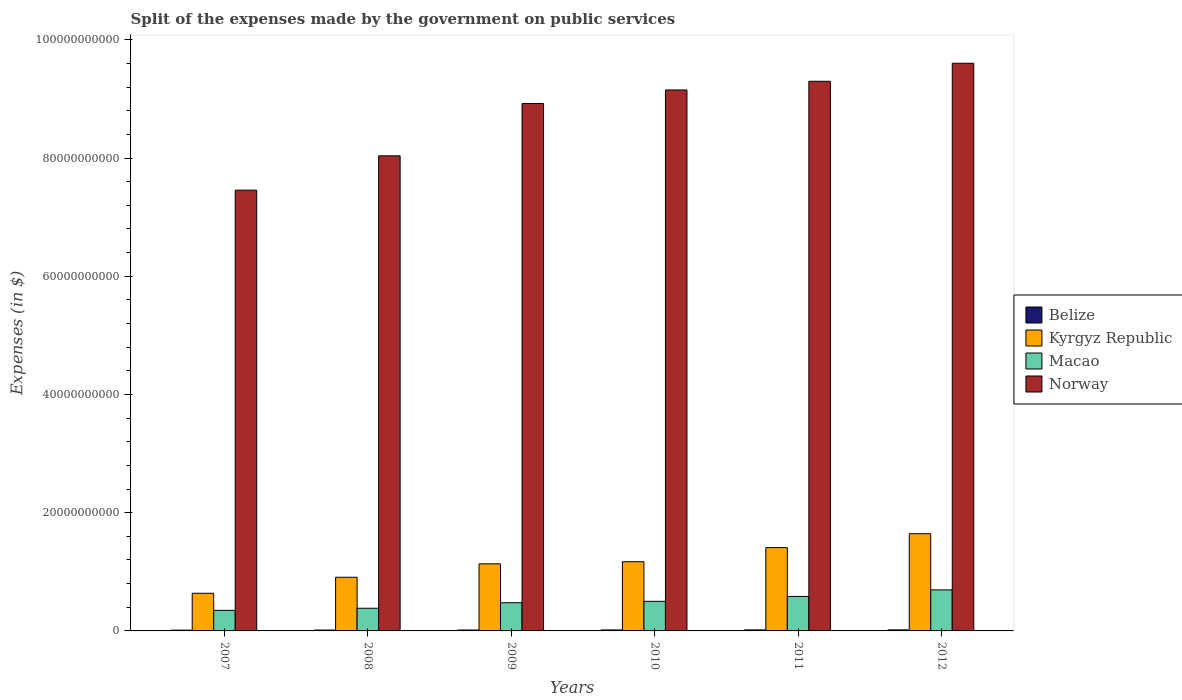How many different coloured bars are there?
Make the answer very short. 4. Are the number of bars per tick equal to the number of legend labels?
Your answer should be very brief. Yes. Are the number of bars on each tick of the X-axis equal?
Your answer should be compact. Yes. What is the expenses made by the government on public services in Kyrgyz Republic in 2010?
Your answer should be compact. 1.17e+1. Across all years, what is the maximum expenses made by the government on public services in Norway?
Your answer should be very brief. 9.60e+1. Across all years, what is the minimum expenses made by the government on public services in Macao?
Keep it short and to the point. 3.48e+09. In which year was the expenses made by the government on public services in Belize maximum?
Your answer should be very brief. 2012. What is the total expenses made by the government on public services in Norway in the graph?
Ensure brevity in your answer.  5.25e+11. What is the difference between the expenses made by the government on public services in Macao in 2009 and that in 2011?
Offer a very short reply. -1.06e+09. What is the difference between the expenses made by the government on public services in Kyrgyz Republic in 2008 and the expenses made by the government on public services in Belize in 2010?
Offer a very short reply. 8.91e+09. What is the average expenses made by the government on public services in Kyrgyz Republic per year?
Your response must be concise. 1.15e+1. In the year 2011, what is the difference between the expenses made by the government on public services in Kyrgyz Republic and expenses made by the government on public services in Macao?
Provide a succinct answer. 8.26e+09. What is the ratio of the expenses made by the government on public services in Macao in 2008 to that in 2011?
Offer a very short reply. 0.66. Is the expenses made by the government on public services in Macao in 2007 less than that in 2011?
Keep it short and to the point. Yes. What is the difference between the highest and the second highest expenses made by the government on public services in Kyrgyz Republic?
Provide a succinct answer. 2.36e+09. What is the difference between the highest and the lowest expenses made by the government on public services in Macao?
Make the answer very short. 3.46e+09. In how many years, is the expenses made by the government on public services in Belize greater than the average expenses made by the government on public services in Belize taken over all years?
Provide a short and direct response. 3. Is the sum of the expenses made by the government on public services in Belize in 2007 and 2012 greater than the maximum expenses made by the government on public services in Kyrgyz Republic across all years?
Provide a succinct answer. No. Is it the case that in every year, the sum of the expenses made by the government on public services in Norway and expenses made by the government on public services in Kyrgyz Republic is greater than the sum of expenses made by the government on public services in Macao and expenses made by the government on public services in Belize?
Provide a short and direct response. Yes. What does the 4th bar from the left in 2009 represents?
Keep it short and to the point. Norway. What does the 4th bar from the right in 2012 represents?
Provide a succinct answer. Belize. Is it the case that in every year, the sum of the expenses made by the government on public services in Norway and expenses made by the government on public services in Belize is greater than the expenses made by the government on public services in Kyrgyz Republic?
Keep it short and to the point. Yes. Does the graph contain any zero values?
Offer a terse response. No. Where does the legend appear in the graph?
Your answer should be very brief. Center right. How are the legend labels stacked?
Keep it short and to the point. Vertical. What is the title of the graph?
Your answer should be compact. Split of the expenses made by the government on public services. What is the label or title of the Y-axis?
Make the answer very short. Expenses (in $). What is the Expenses (in $) in Belize in 2007?
Your answer should be very brief. 1.34e+08. What is the Expenses (in $) of Kyrgyz Republic in 2007?
Provide a succinct answer. 6.37e+09. What is the Expenses (in $) in Macao in 2007?
Give a very brief answer. 3.48e+09. What is the Expenses (in $) in Norway in 2007?
Offer a terse response. 7.46e+1. What is the Expenses (in $) of Belize in 2008?
Make the answer very short. 1.49e+08. What is the Expenses (in $) of Kyrgyz Republic in 2008?
Ensure brevity in your answer.  9.08e+09. What is the Expenses (in $) of Macao in 2008?
Your answer should be very brief. 3.84e+09. What is the Expenses (in $) of Norway in 2008?
Offer a terse response. 8.04e+1. What is the Expenses (in $) of Belize in 2009?
Your response must be concise. 1.58e+08. What is the Expenses (in $) of Kyrgyz Republic in 2009?
Keep it short and to the point. 1.13e+1. What is the Expenses (in $) in Macao in 2009?
Provide a succinct answer. 4.77e+09. What is the Expenses (in $) of Norway in 2009?
Provide a short and direct response. 8.92e+1. What is the Expenses (in $) in Belize in 2010?
Your response must be concise. 1.65e+08. What is the Expenses (in $) of Kyrgyz Republic in 2010?
Offer a terse response. 1.17e+1. What is the Expenses (in $) of Macao in 2010?
Give a very brief answer. 5.01e+09. What is the Expenses (in $) of Norway in 2010?
Your answer should be compact. 9.15e+1. What is the Expenses (in $) in Belize in 2011?
Provide a short and direct response. 1.74e+08. What is the Expenses (in $) of Kyrgyz Republic in 2011?
Give a very brief answer. 1.41e+1. What is the Expenses (in $) in Macao in 2011?
Your answer should be compact. 5.83e+09. What is the Expenses (in $) of Norway in 2011?
Your response must be concise. 9.30e+1. What is the Expenses (in $) of Belize in 2012?
Your answer should be compact. 1.76e+08. What is the Expenses (in $) in Kyrgyz Republic in 2012?
Your answer should be compact. 1.64e+1. What is the Expenses (in $) of Macao in 2012?
Your answer should be compact. 6.94e+09. What is the Expenses (in $) of Norway in 2012?
Make the answer very short. 9.60e+1. Across all years, what is the maximum Expenses (in $) of Belize?
Offer a terse response. 1.76e+08. Across all years, what is the maximum Expenses (in $) in Kyrgyz Republic?
Keep it short and to the point. 1.64e+1. Across all years, what is the maximum Expenses (in $) of Macao?
Offer a terse response. 6.94e+09. Across all years, what is the maximum Expenses (in $) in Norway?
Offer a terse response. 9.60e+1. Across all years, what is the minimum Expenses (in $) in Belize?
Your answer should be compact. 1.34e+08. Across all years, what is the minimum Expenses (in $) in Kyrgyz Republic?
Your answer should be very brief. 6.37e+09. Across all years, what is the minimum Expenses (in $) of Macao?
Provide a succinct answer. 3.48e+09. Across all years, what is the minimum Expenses (in $) in Norway?
Your answer should be very brief. 7.46e+1. What is the total Expenses (in $) of Belize in the graph?
Ensure brevity in your answer.  9.56e+08. What is the total Expenses (in $) of Kyrgyz Republic in the graph?
Give a very brief answer. 6.91e+1. What is the total Expenses (in $) in Macao in the graph?
Offer a very short reply. 2.99e+1. What is the total Expenses (in $) in Norway in the graph?
Your answer should be compact. 5.25e+11. What is the difference between the Expenses (in $) of Belize in 2007 and that in 2008?
Provide a succinct answer. -1.45e+07. What is the difference between the Expenses (in $) in Kyrgyz Republic in 2007 and that in 2008?
Provide a succinct answer. -2.71e+09. What is the difference between the Expenses (in $) of Macao in 2007 and that in 2008?
Keep it short and to the point. -3.57e+08. What is the difference between the Expenses (in $) of Norway in 2007 and that in 2008?
Offer a very short reply. -5.81e+09. What is the difference between the Expenses (in $) of Belize in 2007 and that in 2009?
Provide a succinct answer. -2.38e+07. What is the difference between the Expenses (in $) in Kyrgyz Republic in 2007 and that in 2009?
Keep it short and to the point. -4.98e+09. What is the difference between the Expenses (in $) of Macao in 2007 and that in 2009?
Provide a short and direct response. -1.29e+09. What is the difference between the Expenses (in $) in Norway in 2007 and that in 2009?
Your response must be concise. -1.47e+1. What is the difference between the Expenses (in $) in Belize in 2007 and that in 2010?
Offer a very short reply. -3.07e+07. What is the difference between the Expenses (in $) of Kyrgyz Republic in 2007 and that in 2010?
Offer a very short reply. -5.34e+09. What is the difference between the Expenses (in $) of Macao in 2007 and that in 2010?
Offer a very short reply. -1.53e+09. What is the difference between the Expenses (in $) of Norway in 2007 and that in 2010?
Your response must be concise. -1.70e+1. What is the difference between the Expenses (in $) of Belize in 2007 and that in 2011?
Provide a short and direct response. -3.99e+07. What is the difference between the Expenses (in $) of Kyrgyz Republic in 2007 and that in 2011?
Provide a short and direct response. -7.72e+09. What is the difference between the Expenses (in $) of Macao in 2007 and that in 2011?
Your answer should be very brief. -2.35e+09. What is the difference between the Expenses (in $) in Norway in 2007 and that in 2011?
Provide a succinct answer. -1.84e+1. What is the difference between the Expenses (in $) of Belize in 2007 and that in 2012?
Offer a terse response. -4.19e+07. What is the difference between the Expenses (in $) of Kyrgyz Republic in 2007 and that in 2012?
Keep it short and to the point. -1.01e+1. What is the difference between the Expenses (in $) of Macao in 2007 and that in 2012?
Your response must be concise. -3.46e+09. What is the difference between the Expenses (in $) in Norway in 2007 and that in 2012?
Keep it short and to the point. -2.15e+1. What is the difference between the Expenses (in $) in Belize in 2008 and that in 2009?
Give a very brief answer. -9.31e+06. What is the difference between the Expenses (in $) of Kyrgyz Republic in 2008 and that in 2009?
Provide a succinct answer. -2.27e+09. What is the difference between the Expenses (in $) in Macao in 2008 and that in 2009?
Provide a succinct answer. -9.29e+08. What is the difference between the Expenses (in $) in Norway in 2008 and that in 2009?
Give a very brief answer. -8.85e+09. What is the difference between the Expenses (in $) of Belize in 2008 and that in 2010?
Your answer should be very brief. -1.61e+07. What is the difference between the Expenses (in $) in Kyrgyz Republic in 2008 and that in 2010?
Ensure brevity in your answer.  -2.63e+09. What is the difference between the Expenses (in $) of Macao in 2008 and that in 2010?
Make the answer very short. -1.17e+09. What is the difference between the Expenses (in $) in Norway in 2008 and that in 2010?
Make the answer very short. -1.11e+1. What is the difference between the Expenses (in $) of Belize in 2008 and that in 2011?
Your answer should be very brief. -2.54e+07. What is the difference between the Expenses (in $) of Kyrgyz Republic in 2008 and that in 2011?
Make the answer very short. -5.01e+09. What is the difference between the Expenses (in $) in Macao in 2008 and that in 2011?
Your answer should be compact. -1.99e+09. What is the difference between the Expenses (in $) in Norway in 2008 and that in 2011?
Provide a short and direct response. -1.26e+1. What is the difference between the Expenses (in $) in Belize in 2008 and that in 2012?
Your answer should be compact. -2.74e+07. What is the difference between the Expenses (in $) of Kyrgyz Republic in 2008 and that in 2012?
Keep it short and to the point. -7.37e+09. What is the difference between the Expenses (in $) in Macao in 2008 and that in 2012?
Offer a very short reply. -3.10e+09. What is the difference between the Expenses (in $) in Norway in 2008 and that in 2012?
Your answer should be very brief. -1.57e+1. What is the difference between the Expenses (in $) of Belize in 2009 and that in 2010?
Provide a succinct answer. -6.82e+06. What is the difference between the Expenses (in $) of Kyrgyz Republic in 2009 and that in 2010?
Ensure brevity in your answer.  -3.61e+08. What is the difference between the Expenses (in $) in Macao in 2009 and that in 2010?
Keep it short and to the point. -2.40e+08. What is the difference between the Expenses (in $) of Norway in 2009 and that in 2010?
Offer a terse response. -2.29e+09. What is the difference between the Expenses (in $) in Belize in 2009 and that in 2011?
Your answer should be very brief. -1.61e+07. What is the difference between the Expenses (in $) in Kyrgyz Republic in 2009 and that in 2011?
Keep it short and to the point. -2.74e+09. What is the difference between the Expenses (in $) in Macao in 2009 and that in 2011?
Provide a succinct answer. -1.06e+09. What is the difference between the Expenses (in $) of Norway in 2009 and that in 2011?
Provide a short and direct response. -3.76e+09. What is the difference between the Expenses (in $) in Belize in 2009 and that in 2012?
Provide a short and direct response. -1.80e+07. What is the difference between the Expenses (in $) in Kyrgyz Republic in 2009 and that in 2012?
Give a very brief answer. -5.10e+09. What is the difference between the Expenses (in $) in Macao in 2009 and that in 2012?
Provide a succinct answer. -2.17e+09. What is the difference between the Expenses (in $) of Norway in 2009 and that in 2012?
Offer a very short reply. -6.81e+09. What is the difference between the Expenses (in $) of Belize in 2010 and that in 2011?
Make the answer very short. -9.27e+06. What is the difference between the Expenses (in $) of Kyrgyz Republic in 2010 and that in 2011?
Ensure brevity in your answer.  -2.38e+09. What is the difference between the Expenses (in $) in Macao in 2010 and that in 2011?
Your answer should be very brief. -8.24e+08. What is the difference between the Expenses (in $) in Norway in 2010 and that in 2011?
Your answer should be very brief. -1.47e+09. What is the difference between the Expenses (in $) in Belize in 2010 and that in 2012?
Keep it short and to the point. -1.12e+07. What is the difference between the Expenses (in $) in Kyrgyz Republic in 2010 and that in 2012?
Your answer should be compact. -4.74e+09. What is the difference between the Expenses (in $) in Macao in 2010 and that in 2012?
Offer a very short reply. -1.93e+09. What is the difference between the Expenses (in $) in Norway in 2010 and that in 2012?
Offer a very short reply. -4.52e+09. What is the difference between the Expenses (in $) in Belize in 2011 and that in 2012?
Your response must be concise. -1.96e+06. What is the difference between the Expenses (in $) of Kyrgyz Republic in 2011 and that in 2012?
Offer a terse response. -2.36e+09. What is the difference between the Expenses (in $) of Macao in 2011 and that in 2012?
Your answer should be very brief. -1.11e+09. What is the difference between the Expenses (in $) of Norway in 2011 and that in 2012?
Your answer should be very brief. -3.05e+09. What is the difference between the Expenses (in $) in Belize in 2007 and the Expenses (in $) in Kyrgyz Republic in 2008?
Ensure brevity in your answer.  -8.95e+09. What is the difference between the Expenses (in $) of Belize in 2007 and the Expenses (in $) of Macao in 2008?
Your answer should be very brief. -3.70e+09. What is the difference between the Expenses (in $) in Belize in 2007 and the Expenses (in $) in Norway in 2008?
Offer a terse response. -8.02e+1. What is the difference between the Expenses (in $) of Kyrgyz Republic in 2007 and the Expenses (in $) of Macao in 2008?
Offer a very short reply. 2.53e+09. What is the difference between the Expenses (in $) in Kyrgyz Republic in 2007 and the Expenses (in $) in Norway in 2008?
Your response must be concise. -7.40e+1. What is the difference between the Expenses (in $) of Macao in 2007 and the Expenses (in $) of Norway in 2008?
Make the answer very short. -7.69e+1. What is the difference between the Expenses (in $) of Belize in 2007 and the Expenses (in $) of Kyrgyz Republic in 2009?
Your answer should be very brief. -1.12e+1. What is the difference between the Expenses (in $) in Belize in 2007 and the Expenses (in $) in Macao in 2009?
Your answer should be very brief. -4.63e+09. What is the difference between the Expenses (in $) in Belize in 2007 and the Expenses (in $) in Norway in 2009?
Your answer should be very brief. -8.91e+1. What is the difference between the Expenses (in $) in Kyrgyz Republic in 2007 and the Expenses (in $) in Macao in 2009?
Provide a succinct answer. 1.60e+09. What is the difference between the Expenses (in $) of Kyrgyz Republic in 2007 and the Expenses (in $) of Norway in 2009?
Offer a terse response. -8.29e+1. What is the difference between the Expenses (in $) in Macao in 2007 and the Expenses (in $) in Norway in 2009?
Ensure brevity in your answer.  -8.57e+1. What is the difference between the Expenses (in $) of Belize in 2007 and the Expenses (in $) of Kyrgyz Republic in 2010?
Offer a terse response. -1.16e+1. What is the difference between the Expenses (in $) in Belize in 2007 and the Expenses (in $) in Macao in 2010?
Provide a short and direct response. -4.87e+09. What is the difference between the Expenses (in $) in Belize in 2007 and the Expenses (in $) in Norway in 2010?
Keep it short and to the point. -9.14e+1. What is the difference between the Expenses (in $) in Kyrgyz Republic in 2007 and the Expenses (in $) in Macao in 2010?
Offer a terse response. 1.36e+09. What is the difference between the Expenses (in $) in Kyrgyz Republic in 2007 and the Expenses (in $) in Norway in 2010?
Provide a succinct answer. -8.51e+1. What is the difference between the Expenses (in $) of Macao in 2007 and the Expenses (in $) of Norway in 2010?
Your answer should be compact. -8.80e+1. What is the difference between the Expenses (in $) of Belize in 2007 and the Expenses (in $) of Kyrgyz Republic in 2011?
Ensure brevity in your answer.  -1.40e+1. What is the difference between the Expenses (in $) in Belize in 2007 and the Expenses (in $) in Macao in 2011?
Your response must be concise. -5.70e+09. What is the difference between the Expenses (in $) in Belize in 2007 and the Expenses (in $) in Norway in 2011?
Give a very brief answer. -9.29e+1. What is the difference between the Expenses (in $) in Kyrgyz Republic in 2007 and the Expenses (in $) in Macao in 2011?
Ensure brevity in your answer.  5.41e+08. What is the difference between the Expenses (in $) in Kyrgyz Republic in 2007 and the Expenses (in $) in Norway in 2011?
Your answer should be compact. -8.66e+1. What is the difference between the Expenses (in $) in Macao in 2007 and the Expenses (in $) in Norway in 2011?
Ensure brevity in your answer.  -8.95e+1. What is the difference between the Expenses (in $) in Belize in 2007 and the Expenses (in $) in Kyrgyz Republic in 2012?
Offer a very short reply. -1.63e+1. What is the difference between the Expenses (in $) of Belize in 2007 and the Expenses (in $) of Macao in 2012?
Keep it short and to the point. -6.81e+09. What is the difference between the Expenses (in $) of Belize in 2007 and the Expenses (in $) of Norway in 2012?
Provide a short and direct response. -9.59e+1. What is the difference between the Expenses (in $) of Kyrgyz Republic in 2007 and the Expenses (in $) of Macao in 2012?
Your answer should be compact. -5.70e+08. What is the difference between the Expenses (in $) in Kyrgyz Republic in 2007 and the Expenses (in $) in Norway in 2012?
Your answer should be compact. -8.97e+1. What is the difference between the Expenses (in $) of Macao in 2007 and the Expenses (in $) of Norway in 2012?
Your answer should be very brief. -9.26e+1. What is the difference between the Expenses (in $) of Belize in 2008 and the Expenses (in $) of Kyrgyz Republic in 2009?
Your answer should be very brief. -1.12e+1. What is the difference between the Expenses (in $) of Belize in 2008 and the Expenses (in $) of Macao in 2009?
Your answer should be very brief. -4.62e+09. What is the difference between the Expenses (in $) in Belize in 2008 and the Expenses (in $) in Norway in 2009?
Keep it short and to the point. -8.91e+1. What is the difference between the Expenses (in $) in Kyrgyz Republic in 2008 and the Expenses (in $) in Macao in 2009?
Your answer should be very brief. 4.31e+09. What is the difference between the Expenses (in $) of Kyrgyz Republic in 2008 and the Expenses (in $) of Norway in 2009?
Your response must be concise. -8.02e+1. What is the difference between the Expenses (in $) of Macao in 2008 and the Expenses (in $) of Norway in 2009?
Your response must be concise. -8.54e+1. What is the difference between the Expenses (in $) in Belize in 2008 and the Expenses (in $) in Kyrgyz Republic in 2010?
Make the answer very short. -1.16e+1. What is the difference between the Expenses (in $) in Belize in 2008 and the Expenses (in $) in Macao in 2010?
Ensure brevity in your answer.  -4.86e+09. What is the difference between the Expenses (in $) of Belize in 2008 and the Expenses (in $) of Norway in 2010?
Your answer should be compact. -9.14e+1. What is the difference between the Expenses (in $) of Kyrgyz Republic in 2008 and the Expenses (in $) of Macao in 2010?
Offer a terse response. 4.07e+09. What is the difference between the Expenses (in $) in Kyrgyz Republic in 2008 and the Expenses (in $) in Norway in 2010?
Your answer should be very brief. -8.24e+1. What is the difference between the Expenses (in $) in Macao in 2008 and the Expenses (in $) in Norway in 2010?
Your answer should be very brief. -8.77e+1. What is the difference between the Expenses (in $) of Belize in 2008 and the Expenses (in $) of Kyrgyz Republic in 2011?
Keep it short and to the point. -1.39e+1. What is the difference between the Expenses (in $) in Belize in 2008 and the Expenses (in $) in Macao in 2011?
Your answer should be very brief. -5.68e+09. What is the difference between the Expenses (in $) of Belize in 2008 and the Expenses (in $) of Norway in 2011?
Your answer should be compact. -9.28e+1. What is the difference between the Expenses (in $) in Kyrgyz Republic in 2008 and the Expenses (in $) in Macao in 2011?
Offer a terse response. 3.25e+09. What is the difference between the Expenses (in $) in Kyrgyz Republic in 2008 and the Expenses (in $) in Norway in 2011?
Offer a terse response. -8.39e+1. What is the difference between the Expenses (in $) in Macao in 2008 and the Expenses (in $) in Norway in 2011?
Your answer should be compact. -8.92e+1. What is the difference between the Expenses (in $) of Belize in 2008 and the Expenses (in $) of Kyrgyz Republic in 2012?
Your answer should be very brief. -1.63e+1. What is the difference between the Expenses (in $) of Belize in 2008 and the Expenses (in $) of Macao in 2012?
Provide a succinct answer. -6.79e+09. What is the difference between the Expenses (in $) in Belize in 2008 and the Expenses (in $) in Norway in 2012?
Provide a succinct answer. -9.59e+1. What is the difference between the Expenses (in $) of Kyrgyz Republic in 2008 and the Expenses (in $) of Macao in 2012?
Your response must be concise. 2.14e+09. What is the difference between the Expenses (in $) in Kyrgyz Republic in 2008 and the Expenses (in $) in Norway in 2012?
Your answer should be very brief. -8.70e+1. What is the difference between the Expenses (in $) of Macao in 2008 and the Expenses (in $) of Norway in 2012?
Offer a very short reply. -9.22e+1. What is the difference between the Expenses (in $) of Belize in 2009 and the Expenses (in $) of Kyrgyz Republic in 2010?
Your response must be concise. -1.16e+1. What is the difference between the Expenses (in $) in Belize in 2009 and the Expenses (in $) in Macao in 2010?
Ensure brevity in your answer.  -4.85e+09. What is the difference between the Expenses (in $) of Belize in 2009 and the Expenses (in $) of Norway in 2010?
Provide a short and direct response. -9.14e+1. What is the difference between the Expenses (in $) of Kyrgyz Republic in 2009 and the Expenses (in $) of Macao in 2010?
Offer a very short reply. 6.34e+09. What is the difference between the Expenses (in $) in Kyrgyz Republic in 2009 and the Expenses (in $) in Norway in 2010?
Make the answer very short. -8.02e+1. What is the difference between the Expenses (in $) of Macao in 2009 and the Expenses (in $) of Norway in 2010?
Offer a very short reply. -8.68e+1. What is the difference between the Expenses (in $) of Belize in 2009 and the Expenses (in $) of Kyrgyz Republic in 2011?
Make the answer very short. -1.39e+1. What is the difference between the Expenses (in $) in Belize in 2009 and the Expenses (in $) in Macao in 2011?
Offer a very short reply. -5.67e+09. What is the difference between the Expenses (in $) in Belize in 2009 and the Expenses (in $) in Norway in 2011?
Ensure brevity in your answer.  -9.28e+1. What is the difference between the Expenses (in $) in Kyrgyz Republic in 2009 and the Expenses (in $) in Macao in 2011?
Offer a terse response. 5.52e+09. What is the difference between the Expenses (in $) of Kyrgyz Republic in 2009 and the Expenses (in $) of Norway in 2011?
Give a very brief answer. -8.16e+1. What is the difference between the Expenses (in $) in Macao in 2009 and the Expenses (in $) in Norway in 2011?
Ensure brevity in your answer.  -8.82e+1. What is the difference between the Expenses (in $) of Belize in 2009 and the Expenses (in $) of Kyrgyz Republic in 2012?
Provide a succinct answer. -1.63e+1. What is the difference between the Expenses (in $) in Belize in 2009 and the Expenses (in $) in Macao in 2012?
Give a very brief answer. -6.78e+09. What is the difference between the Expenses (in $) of Belize in 2009 and the Expenses (in $) of Norway in 2012?
Your response must be concise. -9.59e+1. What is the difference between the Expenses (in $) in Kyrgyz Republic in 2009 and the Expenses (in $) in Macao in 2012?
Keep it short and to the point. 4.41e+09. What is the difference between the Expenses (in $) in Kyrgyz Republic in 2009 and the Expenses (in $) in Norway in 2012?
Your answer should be very brief. -8.47e+1. What is the difference between the Expenses (in $) in Macao in 2009 and the Expenses (in $) in Norway in 2012?
Provide a short and direct response. -9.13e+1. What is the difference between the Expenses (in $) of Belize in 2010 and the Expenses (in $) of Kyrgyz Republic in 2011?
Give a very brief answer. -1.39e+1. What is the difference between the Expenses (in $) of Belize in 2010 and the Expenses (in $) of Macao in 2011?
Offer a very short reply. -5.66e+09. What is the difference between the Expenses (in $) in Belize in 2010 and the Expenses (in $) in Norway in 2011?
Ensure brevity in your answer.  -9.28e+1. What is the difference between the Expenses (in $) of Kyrgyz Republic in 2010 and the Expenses (in $) of Macao in 2011?
Offer a very short reply. 5.88e+09. What is the difference between the Expenses (in $) in Kyrgyz Republic in 2010 and the Expenses (in $) in Norway in 2011?
Make the answer very short. -8.13e+1. What is the difference between the Expenses (in $) in Macao in 2010 and the Expenses (in $) in Norway in 2011?
Ensure brevity in your answer.  -8.80e+1. What is the difference between the Expenses (in $) of Belize in 2010 and the Expenses (in $) of Kyrgyz Republic in 2012?
Provide a short and direct response. -1.63e+1. What is the difference between the Expenses (in $) in Belize in 2010 and the Expenses (in $) in Macao in 2012?
Offer a terse response. -6.78e+09. What is the difference between the Expenses (in $) of Belize in 2010 and the Expenses (in $) of Norway in 2012?
Keep it short and to the point. -9.59e+1. What is the difference between the Expenses (in $) of Kyrgyz Republic in 2010 and the Expenses (in $) of Macao in 2012?
Keep it short and to the point. 4.77e+09. What is the difference between the Expenses (in $) in Kyrgyz Republic in 2010 and the Expenses (in $) in Norway in 2012?
Ensure brevity in your answer.  -8.43e+1. What is the difference between the Expenses (in $) in Macao in 2010 and the Expenses (in $) in Norway in 2012?
Ensure brevity in your answer.  -9.10e+1. What is the difference between the Expenses (in $) of Belize in 2011 and the Expenses (in $) of Kyrgyz Republic in 2012?
Offer a very short reply. -1.63e+1. What is the difference between the Expenses (in $) of Belize in 2011 and the Expenses (in $) of Macao in 2012?
Your answer should be compact. -6.77e+09. What is the difference between the Expenses (in $) of Belize in 2011 and the Expenses (in $) of Norway in 2012?
Give a very brief answer. -9.59e+1. What is the difference between the Expenses (in $) in Kyrgyz Republic in 2011 and the Expenses (in $) in Macao in 2012?
Ensure brevity in your answer.  7.15e+09. What is the difference between the Expenses (in $) of Kyrgyz Republic in 2011 and the Expenses (in $) of Norway in 2012?
Your answer should be very brief. -8.19e+1. What is the difference between the Expenses (in $) in Macao in 2011 and the Expenses (in $) in Norway in 2012?
Give a very brief answer. -9.02e+1. What is the average Expenses (in $) in Belize per year?
Your answer should be compact. 1.59e+08. What is the average Expenses (in $) of Kyrgyz Republic per year?
Offer a terse response. 1.15e+1. What is the average Expenses (in $) of Macao per year?
Provide a succinct answer. 4.98e+09. What is the average Expenses (in $) in Norway per year?
Provide a short and direct response. 8.75e+1. In the year 2007, what is the difference between the Expenses (in $) of Belize and Expenses (in $) of Kyrgyz Republic?
Provide a succinct answer. -6.24e+09. In the year 2007, what is the difference between the Expenses (in $) in Belize and Expenses (in $) in Macao?
Your answer should be very brief. -3.35e+09. In the year 2007, what is the difference between the Expenses (in $) of Belize and Expenses (in $) of Norway?
Offer a terse response. -7.44e+1. In the year 2007, what is the difference between the Expenses (in $) in Kyrgyz Republic and Expenses (in $) in Macao?
Your response must be concise. 2.89e+09. In the year 2007, what is the difference between the Expenses (in $) in Kyrgyz Republic and Expenses (in $) in Norway?
Ensure brevity in your answer.  -6.82e+1. In the year 2007, what is the difference between the Expenses (in $) in Macao and Expenses (in $) in Norway?
Ensure brevity in your answer.  -7.11e+1. In the year 2008, what is the difference between the Expenses (in $) in Belize and Expenses (in $) in Kyrgyz Republic?
Provide a succinct answer. -8.93e+09. In the year 2008, what is the difference between the Expenses (in $) of Belize and Expenses (in $) of Macao?
Your answer should be very brief. -3.69e+09. In the year 2008, what is the difference between the Expenses (in $) in Belize and Expenses (in $) in Norway?
Offer a very short reply. -8.02e+1. In the year 2008, what is the difference between the Expenses (in $) in Kyrgyz Republic and Expenses (in $) in Macao?
Offer a terse response. 5.24e+09. In the year 2008, what is the difference between the Expenses (in $) in Kyrgyz Republic and Expenses (in $) in Norway?
Offer a very short reply. -7.13e+1. In the year 2008, what is the difference between the Expenses (in $) in Macao and Expenses (in $) in Norway?
Give a very brief answer. -7.65e+1. In the year 2009, what is the difference between the Expenses (in $) in Belize and Expenses (in $) in Kyrgyz Republic?
Your answer should be compact. -1.12e+1. In the year 2009, what is the difference between the Expenses (in $) in Belize and Expenses (in $) in Macao?
Give a very brief answer. -4.61e+09. In the year 2009, what is the difference between the Expenses (in $) in Belize and Expenses (in $) in Norway?
Ensure brevity in your answer.  -8.91e+1. In the year 2009, what is the difference between the Expenses (in $) in Kyrgyz Republic and Expenses (in $) in Macao?
Keep it short and to the point. 6.58e+09. In the year 2009, what is the difference between the Expenses (in $) of Kyrgyz Republic and Expenses (in $) of Norway?
Ensure brevity in your answer.  -7.79e+1. In the year 2009, what is the difference between the Expenses (in $) in Macao and Expenses (in $) in Norway?
Your response must be concise. -8.45e+1. In the year 2010, what is the difference between the Expenses (in $) in Belize and Expenses (in $) in Kyrgyz Republic?
Give a very brief answer. -1.15e+1. In the year 2010, what is the difference between the Expenses (in $) in Belize and Expenses (in $) in Macao?
Your answer should be compact. -4.84e+09. In the year 2010, what is the difference between the Expenses (in $) in Belize and Expenses (in $) in Norway?
Keep it short and to the point. -9.14e+1. In the year 2010, what is the difference between the Expenses (in $) of Kyrgyz Republic and Expenses (in $) of Macao?
Ensure brevity in your answer.  6.70e+09. In the year 2010, what is the difference between the Expenses (in $) of Kyrgyz Republic and Expenses (in $) of Norway?
Make the answer very short. -7.98e+1. In the year 2010, what is the difference between the Expenses (in $) in Macao and Expenses (in $) in Norway?
Give a very brief answer. -8.65e+1. In the year 2011, what is the difference between the Expenses (in $) in Belize and Expenses (in $) in Kyrgyz Republic?
Offer a terse response. -1.39e+1. In the year 2011, what is the difference between the Expenses (in $) in Belize and Expenses (in $) in Macao?
Give a very brief answer. -5.66e+09. In the year 2011, what is the difference between the Expenses (in $) in Belize and Expenses (in $) in Norway?
Offer a terse response. -9.28e+1. In the year 2011, what is the difference between the Expenses (in $) of Kyrgyz Republic and Expenses (in $) of Macao?
Provide a succinct answer. 8.26e+09. In the year 2011, what is the difference between the Expenses (in $) of Kyrgyz Republic and Expenses (in $) of Norway?
Give a very brief answer. -7.89e+1. In the year 2011, what is the difference between the Expenses (in $) in Macao and Expenses (in $) in Norway?
Give a very brief answer. -8.72e+1. In the year 2012, what is the difference between the Expenses (in $) in Belize and Expenses (in $) in Kyrgyz Republic?
Offer a terse response. -1.63e+1. In the year 2012, what is the difference between the Expenses (in $) in Belize and Expenses (in $) in Macao?
Keep it short and to the point. -6.76e+09. In the year 2012, what is the difference between the Expenses (in $) of Belize and Expenses (in $) of Norway?
Your answer should be compact. -9.59e+1. In the year 2012, what is the difference between the Expenses (in $) in Kyrgyz Republic and Expenses (in $) in Macao?
Provide a succinct answer. 9.51e+09. In the year 2012, what is the difference between the Expenses (in $) in Kyrgyz Republic and Expenses (in $) in Norway?
Your response must be concise. -7.96e+1. In the year 2012, what is the difference between the Expenses (in $) of Macao and Expenses (in $) of Norway?
Offer a terse response. -8.91e+1. What is the ratio of the Expenses (in $) in Belize in 2007 to that in 2008?
Ensure brevity in your answer.  0.9. What is the ratio of the Expenses (in $) in Kyrgyz Republic in 2007 to that in 2008?
Your response must be concise. 0.7. What is the ratio of the Expenses (in $) in Macao in 2007 to that in 2008?
Keep it short and to the point. 0.91. What is the ratio of the Expenses (in $) in Norway in 2007 to that in 2008?
Your answer should be very brief. 0.93. What is the ratio of the Expenses (in $) in Belize in 2007 to that in 2009?
Offer a terse response. 0.85. What is the ratio of the Expenses (in $) of Kyrgyz Republic in 2007 to that in 2009?
Offer a very short reply. 0.56. What is the ratio of the Expenses (in $) in Macao in 2007 to that in 2009?
Your answer should be compact. 0.73. What is the ratio of the Expenses (in $) of Norway in 2007 to that in 2009?
Your answer should be compact. 0.84. What is the ratio of the Expenses (in $) in Belize in 2007 to that in 2010?
Keep it short and to the point. 0.81. What is the ratio of the Expenses (in $) of Kyrgyz Republic in 2007 to that in 2010?
Keep it short and to the point. 0.54. What is the ratio of the Expenses (in $) of Macao in 2007 to that in 2010?
Provide a short and direct response. 0.7. What is the ratio of the Expenses (in $) of Norway in 2007 to that in 2010?
Give a very brief answer. 0.81. What is the ratio of the Expenses (in $) in Belize in 2007 to that in 2011?
Keep it short and to the point. 0.77. What is the ratio of the Expenses (in $) of Kyrgyz Republic in 2007 to that in 2011?
Ensure brevity in your answer.  0.45. What is the ratio of the Expenses (in $) of Macao in 2007 to that in 2011?
Your answer should be very brief. 0.6. What is the ratio of the Expenses (in $) in Norway in 2007 to that in 2011?
Ensure brevity in your answer.  0.8. What is the ratio of the Expenses (in $) in Belize in 2007 to that in 2012?
Provide a short and direct response. 0.76. What is the ratio of the Expenses (in $) in Kyrgyz Republic in 2007 to that in 2012?
Ensure brevity in your answer.  0.39. What is the ratio of the Expenses (in $) in Macao in 2007 to that in 2012?
Your answer should be very brief. 0.5. What is the ratio of the Expenses (in $) in Norway in 2007 to that in 2012?
Your answer should be very brief. 0.78. What is the ratio of the Expenses (in $) of Belize in 2008 to that in 2009?
Your response must be concise. 0.94. What is the ratio of the Expenses (in $) in Kyrgyz Republic in 2008 to that in 2009?
Offer a terse response. 0.8. What is the ratio of the Expenses (in $) of Macao in 2008 to that in 2009?
Offer a terse response. 0.81. What is the ratio of the Expenses (in $) in Norway in 2008 to that in 2009?
Offer a terse response. 0.9. What is the ratio of the Expenses (in $) of Belize in 2008 to that in 2010?
Give a very brief answer. 0.9. What is the ratio of the Expenses (in $) in Kyrgyz Republic in 2008 to that in 2010?
Your response must be concise. 0.78. What is the ratio of the Expenses (in $) in Macao in 2008 to that in 2010?
Keep it short and to the point. 0.77. What is the ratio of the Expenses (in $) of Norway in 2008 to that in 2010?
Keep it short and to the point. 0.88. What is the ratio of the Expenses (in $) in Belize in 2008 to that in 2011?
Offer a terse response. 0.85. What is the ratio of the Expenses (in $) of Kyrgyz Republic in 2008 to that in 2011?
Offer a very short reply. 0.64. What is the ratio of the Expenses (in $) of Macao in 2008 to that in 2011?
Offer a very short reply. 0.66. What is the ratio of the Expenses (in $) in Norway in 2008 to that in 2011?
Provide a short and direct response. 0.86. What is the ratio of the Expenses (in $) in Belize in 2008 to that in 2012?
Your answer should be compact. 0.84. What is the ratio of the Expenses (in $) of Kyrgyz Republic in 2008 to that in 2012?
Provide a succinct answer. 0.55. What is the ratio of the Expenses (in $) in Macao in 2008 to that in 2012?
Offer a terse response. 0.55. What is the ratio of the Expenses (in $) in Norway in 2008 to that in 2012?
Offer a very short reply. 0.84. What is the ratio of the Expenses (in $) in Belize in 2009 to that in 2010?
Give a very brief answer. 0.96. What is the ratio of the Expenses (in $) of Kyrgyz Republic in 2009 to that in 2010?
Provide a succinct answer. 0.97. What is the ratio of the Expenses (in $) of Macao in 2009 to that in 2010?
Provide a short and direct response. 0.95. What is the ratio of the Expenses (in $) in Norway in 2009 to that in 2010?
Give a very brief answer. 0.97. What is the ratio of the Expenses (in $) in Belize in 2009 to that in 2011?
Keep it short and to the point. 0.91. What is the ratio of the Expenses (in $) in Kyrgyz Republic in 2009 to that in 2011?
Offer a terse response. 0.81. What is the ratio of the Expenses (in $) of Macao in 2009 to that in 2011?
Offer a terse response. 0.82. What is the ratio of the Expenses (in $) in Norway in 2009 to that in 2011?
Make the answer very short. 0.96. What is the ratio of the Expenses (in $) in Belize in 2009 to that in 2012?
Give a very brief answer. 0.9. What is the ratio of the Expenses (in $) in Kyrgyz Republic in 2009 to that in 2012?
Provide a short and direct response. 0.69. What is the ratio of the Expenses (in $) in Macao in 2009 to that in 2012?
Your response must be concise. 0.69. What is the ratio of the Expenses (in $) of Norway in 2009 to that in 2012?
Provide a short and direct response. 0.93. What is the ratio of the Expenses (in $) of Belize in 2010 to that in 2011?
Ensure brevity in your answer.  0.95. What is the ratio of the Expenses (in $) in Kyrgyz Republic in 2010 to that in 2011?
Make the answer very short. 0.83. What is the ratio of the Expenses (in $) of Macao in 2010 to that in 2011?
Provide a succinct answer. 0.86. What is the ratio of the Expenses (in $) in Norway in 2010 to that in 2011?
Your answer should be very brief. 0.98. What is the ratio of the Expenses (in $) of Belize in 2010 to that in 2012?
Provide a short and direct response. 0.94. What is the ratio of the Expenses (in $) of Kyrgyz Republic in 2010 to that in 2012?
Give a very brief answer. 0.71. What is the ratio of the Expenses (in $) of Macao in 2010 to that in 2012?
Keep it short and to the point. 0.72. What is the ratio of the Expenses (in $) in Norway in 2010 to that in 2012?
Your response must be concise. 0.95. What is the ratio of the Expenses (in $) of Belize in 2011 to that in 2012?
Ensure brevity in your answer.  0.99. What is the ratio of the Expenses (in $) in Kyrgyz Republic in 2011 to that in 2012?
Provide a short and direct response. 0.86. What is the ratio of the Expenses (in $) of Macao in 2011 to that in 2012?
Provide a succinct answer. 0.84. What is the ratio of the Expenses (in $) of Norway in 2011 to that in 2012?
Your response must be concise. 0.97. What is the difference between the highest and the second highest Expenses (in $) in Belize?
Give a very brief answer. 1.96e+06. What is the difference between the highest and the second highest Expenses (in $) in Kyrgyz Republic?
Make the answer very short. 2.36e+09. What is the difference between the highest and the second highest Expenses (in $) of Macao?
Make the answer very short. 1.11e+09. What is the difference between the highest and the second highest Expenses (in $) of Norway?
Provide a succinct answer. 3.05e+09. What is the difference between the highest and the lowest Expenses (in $) of Belize?
Provide a succinct answer. 4.19e+07. What is the difference between the highest and the lowest Expenses (in $) of Kyrgyz Republic?
Give a very brief answer. 1.01e+1. What is the difference between the highest and the lowest Expenses (in $) in Macao?
Make the answer very short. 3.46e+09. What is the difference between the highest and the lowest Expenses (in $) of Norway?
Provide a short and direct response. 2.15e+1. 